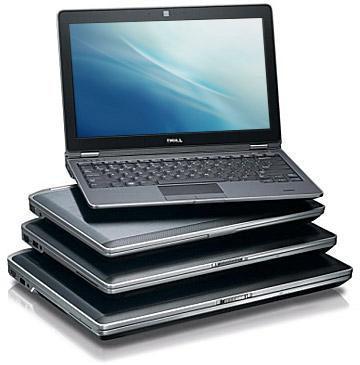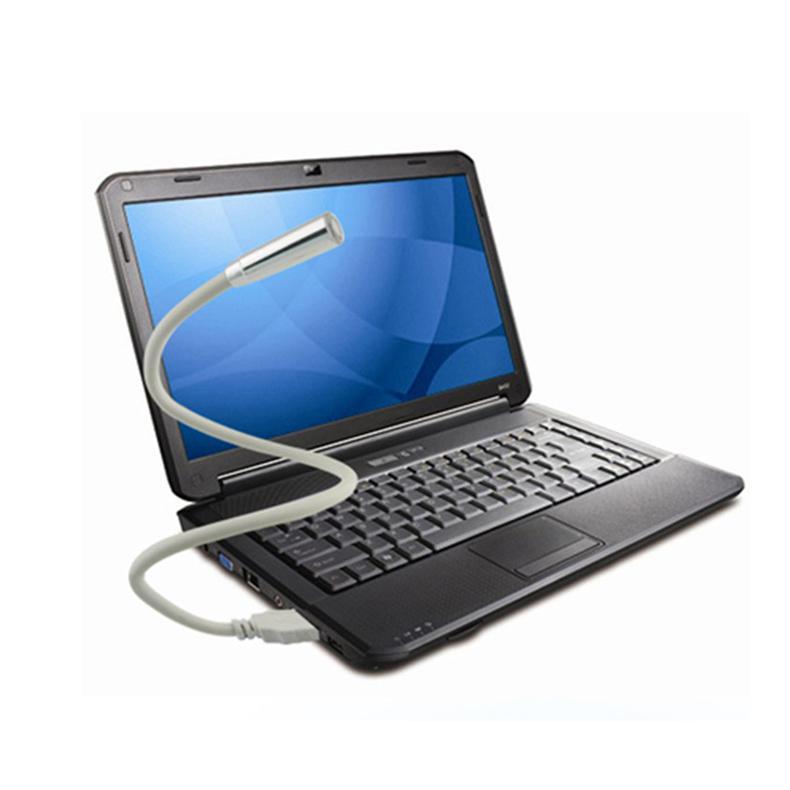The first image is the image on the left, the second image is the image on the right. Assess this claim about the two images: "the laptop in the image on the right is facing the bottom right". Correct or not? Answer yes or no. Yes. 